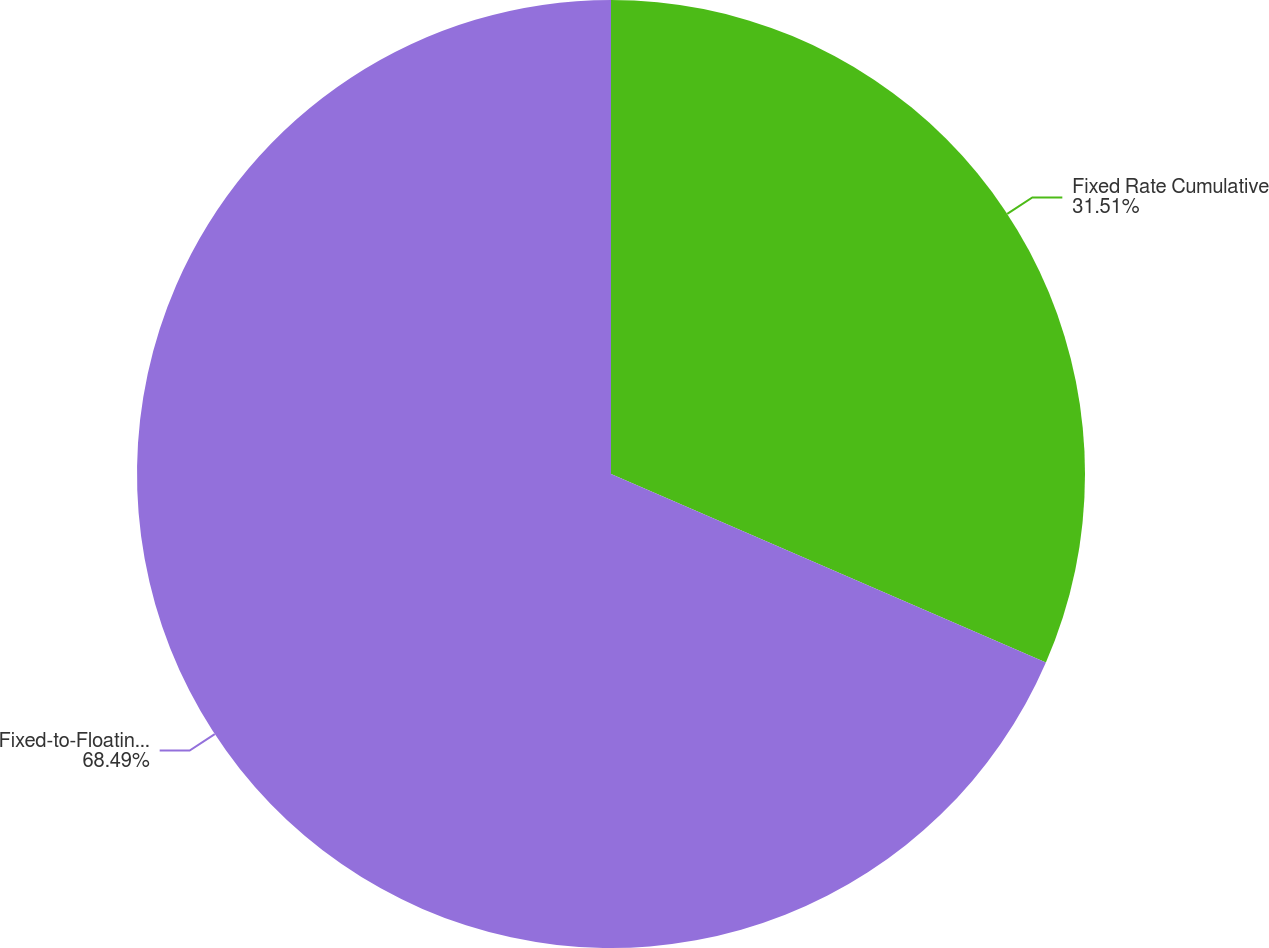Convert chart to OTSL. <chart><loc_0><loc_0><loc_500><loc_500><pie_chart><fcel>Fixed Rate Cumulative<fcel>Fixed-to-Floating Rate<nl><fcel>31.51%<fcel>68.49%<nl></chart> 